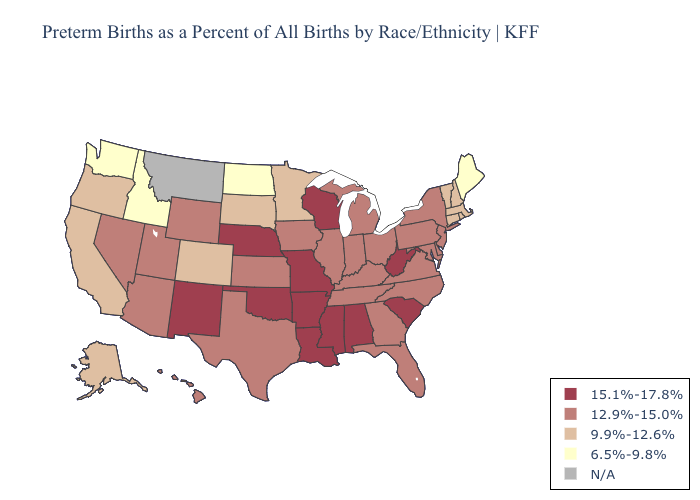Among the states that border Kentucky , does Missouri have the lowest value?
Concise answer only. No. Name the states that have a value in the range 15.1%-17.8%?
Keep it brief. Alabama, Arkansas, Louisiana, Mississippi, Missouri, Nebraska, New Mexico, Oklahoma, South Carolina, West Virginia, Wisconsin. Name the states that have a value in the range N/A?
Short answer required. Montana. Name the states that have a value in the range 12.9%-15.0%?
Be succinct. Arizona, Delaware, Florida, Georgia, Hawaii, Illinois, Indiana, Iowa, Kansas, Kentucky, Maryland, Michigan, Nevada, New Jersey, New York, North Carolina, Ohio, Pennsylvania, Tennessee, Texas, Utah, Virginia, Wyoming. What is the highest value in the South ?
Write a very short answer. 15.1%-17.8%. Does North Dakota have the lowest value in the USA?
Keep it brief. Yes. What is the value of Arkansas?
Short answer required. 15.1%-17.8%. Does Florida have the highest value in the South?
Give a very brief answer. No. Name the states that have a value in the range 15.1%-17.8%?
Write a very short answer. Alabama, Arkansas, Louisiana, Mississippi, Missouri, Nebraska, New Mexico, Oklahoma, South Carolina, West Virginia, Wisconsin. Does New Hampshire have the highest value in the Northeast?
Write a very short answer. No. Does Maine have the highest value in the Northeast?
Give a very brief answer. No. Name the states that have a value in the range 12.9%-15.0%?
Quick response, please. Arizona, Delaware, Florida, Georgia, Hawaii, Illinois, Indiana, Iowa, Kansas, Kentucky, Maryland, Michigan, Nevada, New Jersey, New York, North Carolina, Ohio, Pennsylvania, Tennessee, Texas, Utah, Virginia, Wyoming. Does Alaska have the highest value in the USA?
Answer briefly. No. What is the value of Arkansas?
Quick response, please. 15.1%-17.8%. Name the states that have a value in the range 12.9%-15.0%?
Concise answer only. Arizona, Delaware, Florida, Georgia, Hawaii, Illinois, Indiana, Iowa, Kansas, Kentucky, Maryland, Michigan, Nevada, New Jersey, New York, North Carolina, Ohio, Pennsylvania, Tennessee, Texas, Utah, Virginia, Wyoming. 